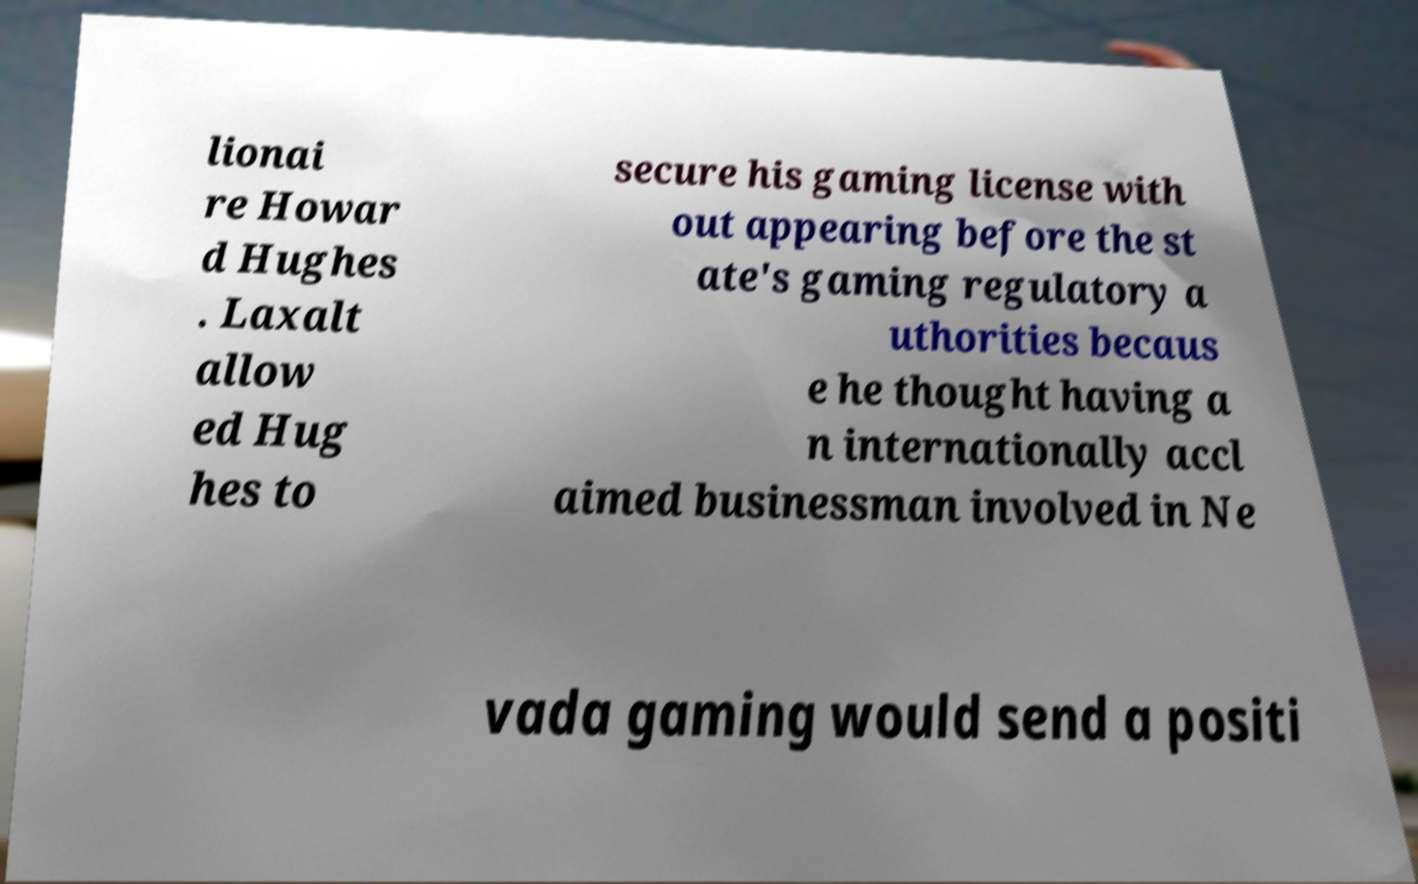What messages or text are displayed in this image? I need them in a readable, typed format. lionai re Howar d Hughes . Laxalt allow ed Hug hes to secure his gaming license with out appearing before the st ate's gaming regulatory a uthorities becaus e he thought having a n internationally accl aimed businessman involved in Ne vada gaming would send a positi 